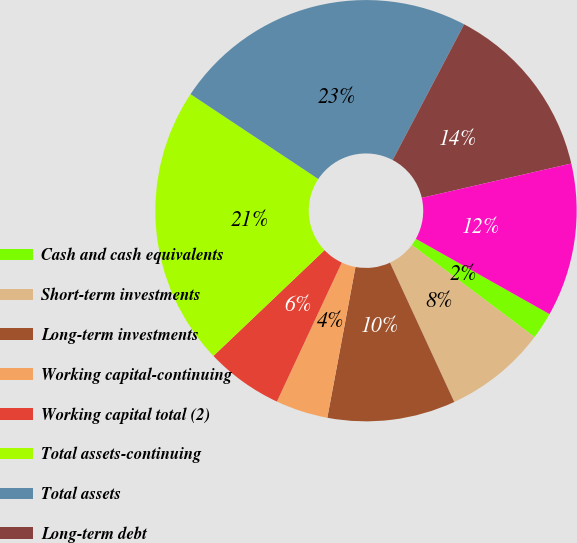<chart> <loc_0><loc_0><loc_500><loc_500><pie_chart><fcel>Cash and cash equivalents<fcel>Short-term investments<fcel>Long-term investments<fcel>Working capital-continuing<fcel>Working capital total (2)<fcel>Total assets-continuing<fcel>Total assets<fcel>Long-term debt<fcel>Total stockholders' equity (4)<nl><fcel>2.07%<fcel>7.88%<fcel>9.82%<fcel>4.01%<fcel>5.94%<fcel>21.44%<fcel>23.38%<fcel>13.69%<fcel>11.76%<nl></chart> 